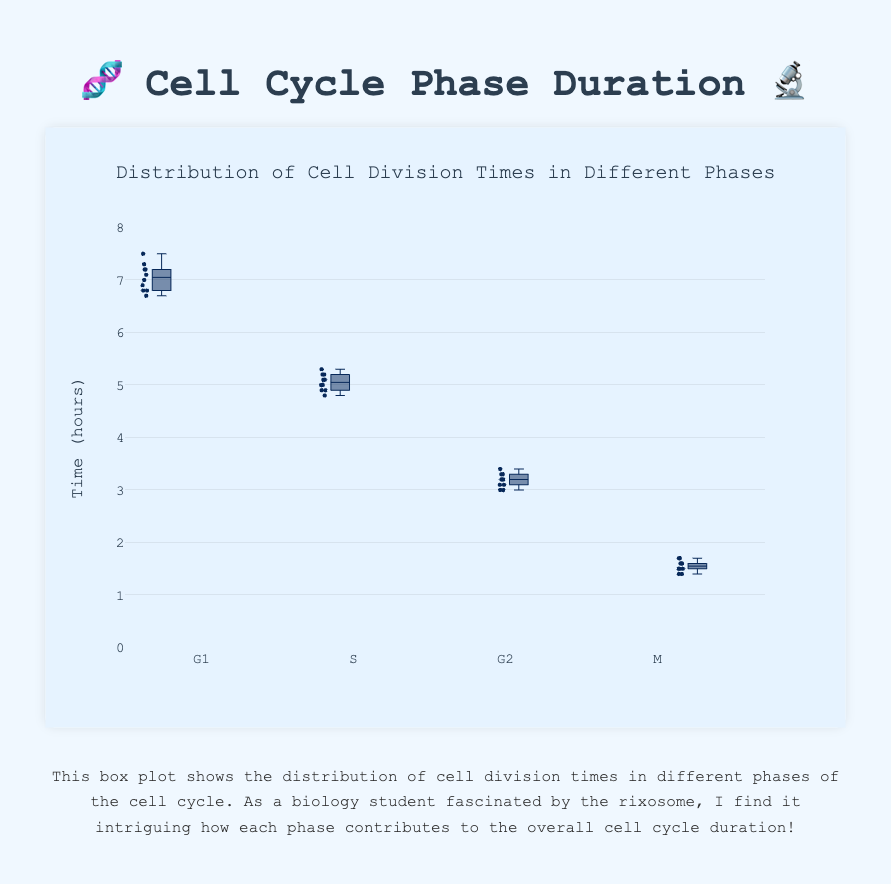What is the median cell division time for the G1 phase? The median is the middle value of the ordered data. For the G1 phase, the ordered times are: 6.7, 6.8, 6.8, 6.9, 7.0, 7.1, 7.2, 7.2, 7.3, 7.5. The median is the average of the 5th and 6th values: (7.0+7.1)/2 = 7.05
Answer: 7.05 Which phase has the shortest median cell division time? The median cell division times for each phase can be observed on the box plots as the central lines. The phase with the lowest central line represents the shortest median. M phase's median is lowest.
Answer: M What is the interquartile range (IQR) for the S phase? IQR is the difference between Q3 (upper quartile) and Q1 (lower quartile). For the S phase, Q1 is approximately 4.9 and Q3 is around 5.2. The IQR is 5.2 - 4.9 = 0.3
Answer: 0.3 How does the variability of cell division times compare between G2 and M phases? Variability is seen through the spread of the box plot. The wider the box and whiskers, the more variable the data. The G2 phase appears to have a wider spread in its box plot compared to the M phase.
Answer: G2 is more variable Which phase has the smallest range of cell division times? The range can be seen as the difference between the highest and lowest points (whiskers) in the box plot. The smallest range is seen in the M phase box plot.
Answer: M What is the approximate upper whisker value for the G1 phase? The upper whisker value in a box plot represents roughly the largest observation within 1.5 IQRs of the upper quartile. For G1, it appears around 7.5.
Answer: ~7.5 Is the distribution of cell division times for the G1 phase skewed? If so, in which direction? Skewness can be inferred if the median is not centered in the box and the whiskers are uneven. For G1, the median is slightly to the left in the box plot, indicating slight right skewness.
Answer: Slightly right-skewed Which cell cycle phase has the most outliers, if any? Outliers are usually shown as points beyond the whiskers. From the box plots, M phase shows no visible outliers, whereas other phases show some potential outliers.
Answer: No phase has notable outliers 